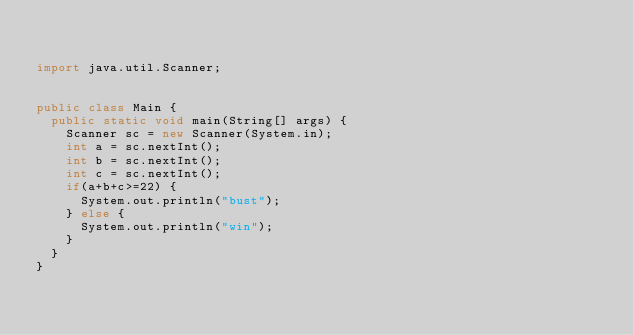<code> <loc_0><loc_0><loc_500><loc_500><_Java_>

import java.util.Scanner;


public class Main {
  public static void main(String[] args) {
    Scanner sc = new Scanner(System.in);
    int a = sc.nextInt();
    int b = sc.nextInt();
    int c = sc.nextInt();
    if(a+b+c>=22) {
      System.out.println("bust");
    } else {
      System.out.println("win");
    }
  }
}
</code> 